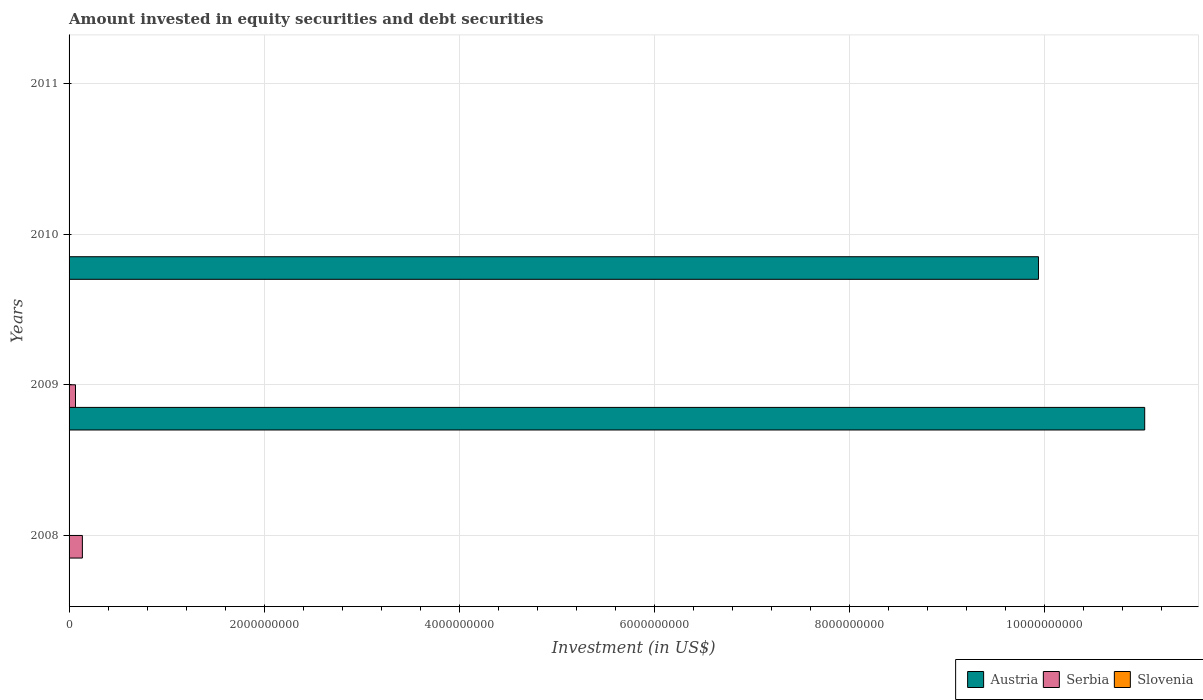Are the number of bars per tick equal to the number of legend labels?
Offer a very short reply. No. Are the number of bars on each tick of the Y-axis equal?
Make the answer very short. No. How many bars are there on the 1st tick from the top?
Provide a succinct answer. 0. What is the label of the 4th group of bars from the top?
Ensure brevity in your answer.  2008. In how many cases, is the number of bars for a given year not equal to the number of legend labels?
Ensure brevity in your answer.  4. What is the amount invested in equity securities and debt securities in Serbia in 2009?
Make the answer very short. 6.57e+07. Across all years, what is the maximum amount invested in equity securities and debt securities in Serbia?
Keep it short and to the point. 1.36e+08. Across all years, what is the minimum amount invested in equity securities and debt securities in Serbia?
Provide a succinct answer. 0. What is the total amount invested in equity securities and debt securities in Serbia in the graph?
Ensure brevity in your answer.  2.02e+08. What is the difference between the amount invested in equity securities and debt securities in Austria in 2009 and that in 2010?
Keep it short and to the point. 1.09e+09. What is the average amount invested in equity securities and debt securities in Serbia per year?
Your answer should be very brief. 5.05e+07. In the year 2009, what is the difference between the amount invested in equity securities and debt securities in Serbia and amount invested in equity securities and debt securities in Austria?
Give a very brief answer. -1.10e+1. What is the ratio of the amount invested in equity securities and debt securities in Austria in 2009 to that in 2010?
Give a very brief answer. 1.11. Is the amount invested in equity securities and debt securities in Austria in 2009 less than that in 2010?
Provide a short and direct response. No. What is the difference between the highest and the lowest amount invested in equity securities and debt securities in Serbia?
Offer a terse response. 1.36e+08. In how many years, is the amount invested in equity securities and debt securities in Austria greater than the average amount invested in equity securities and debt securities in Austria taken over all years?
Ensure brevity in your answer.  2. Is the sum of the amount invested in equity securities and debt securities in Austria in 2009 and 2010 greater than the maximum amount invested in equity securities and debt securities in Serbia across all years?
Provide a succinct answer. Yes. How many bars are there?
Provide a short and direct response. 4. Are all the bars in the graph horizontal?
Your answer should be compact. Yes. What is the difference between two consecutive major ticks on the X-axis?
Your answer should be compact. 2.00e+09. Are the values on the major ticks of X-axis written in scientific E-notation?
Your answer should be compact. No. Does the graph contain any zero values?
Provide a short and direct response. Yes. Where does the legend appear in the graph?
Provide a short and direct response. Bottom right. How many legend labels are there?
Keep it short and to the point. 3. What is the title of the graph?
Make the answer very short. Amount invested in equity securities and debt securities. Does "Angola" appear as one of the legend labels in the graph?
Provide a succinct answer. No. What is the label or title of the X-axis?
Make the answer very short. Investment (in US$). What is the Investment (in US$) in Austria in 2008?
Offer a very short reply. 0. What is the Investment (in US$) in Serbia in 2008?
Your answer should be very brief. 1.36e+08. What is the Investment (in US$) of Austria in 2009?
Keep it short and to the point. 1.10e+1. What is the Investment (in US$) in Serbia in 2009?
Keep it short and to the point. 6.57e+07. What is the Investment (in US$) in Austria in 2010?
Offer a terse response. 9.94e+09. What is the Investment (in US$) of Serbia in 2010?
Your response must be concise. 0. What is the Investment (in US$) of Slovenia in 2010?
Keep it short and to the point. 0. What is the Investment (in US$) in Austria in 2011?
Keep it short and to the point. 0. What is the Investment (in US$) in Slovenia in 2011?
Ensure brevity in your answer.  0. Across all years, what is the maximum Investment (in US$) in Austria?
Your response must be concise. 1.10e+1. Across all years, what is the maximum Investment (in US$) in Serbia?
Provide a short and direct response. 1.36e+08. Across all years, what is the minimum Investment (in US$) in Austria?
Provide a short and direct response. 0. What is the total Investment (in US$) of Austria in the graph?
Give a very brief answer. 2.10e+1. What is the total Investment (in US$) in Serbia in the graph?
Keep it short and to the point. 2.02e+08. What is the total Investment (in US$) in Slovenia in the graph?
Ensure brevity in your answer.  0. What is the difference between the Investment (in US$) of Serbia in 2008 and that in 2009?
Make the answer very short. 7.08e+07. What is the difference between the Investment (in US$) in Austria in 2009 and that in 2010?
Provide a short and direct response. 1.09e+09. What is the average Investment (in US$) in Austria per year?
Offer a terse response. 5.24e+09. What is the average Investment (in US$) of Serbia per year?
Ensure brevity in your answer.  5.05e+07. What is the average Investment (in US$) of Slovenia per year?
Your answer should be very brief. 0. In the year 2009, what is the difference between the Investment (in US$) of Austria and Investment (in US$) of Serbia?
Give a very brief answer. 1.10e+1. What is the ratio of the Investment (in US$) of Serbia in 2008 to that in 2009?
Keep it short and to the point. 2.08. What is the ratio of the Investment (in US$) of Austria in 2009 to that in 2010?
Keep it short and to the point. 1.11. What is the difference between the highest and the lowest Investment (in US$) of Austria?
Ensure brevity in your answer.  1.10e+1. What is the difference between the highest and the lowest Investment (in US$) of Serbia?
Make the answer very short. 1.36e+08. 